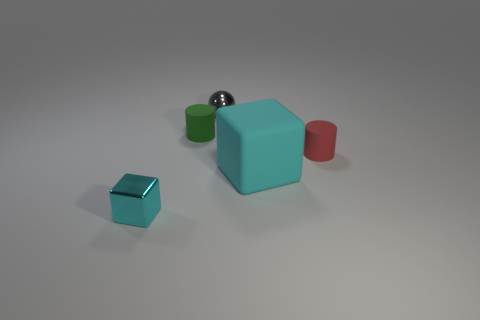Add 3 cubes. How many objects exist? 8 Subtract 1 cubes. How many cubes are left? 1 Subtract all gray balls. How many red cylinders are left? 1 Subtract all cyan metal cylinders. Subtract all large cyan matte cubes. How many objects are left? 4 Add 4 tiny rubber things. How many tiny rubber things are left? 6 Add 5 spheres. How many spheres exist? 6 Subtract all green cylinders. How many cylinders are left? 1 Subtract 0 yellow blocks. How many objects are left? 5 Subtract all balls. How many objects are left? 4 Subtract all red cylinders. Subtract all gray spheres. How many cylinders are left? 1 